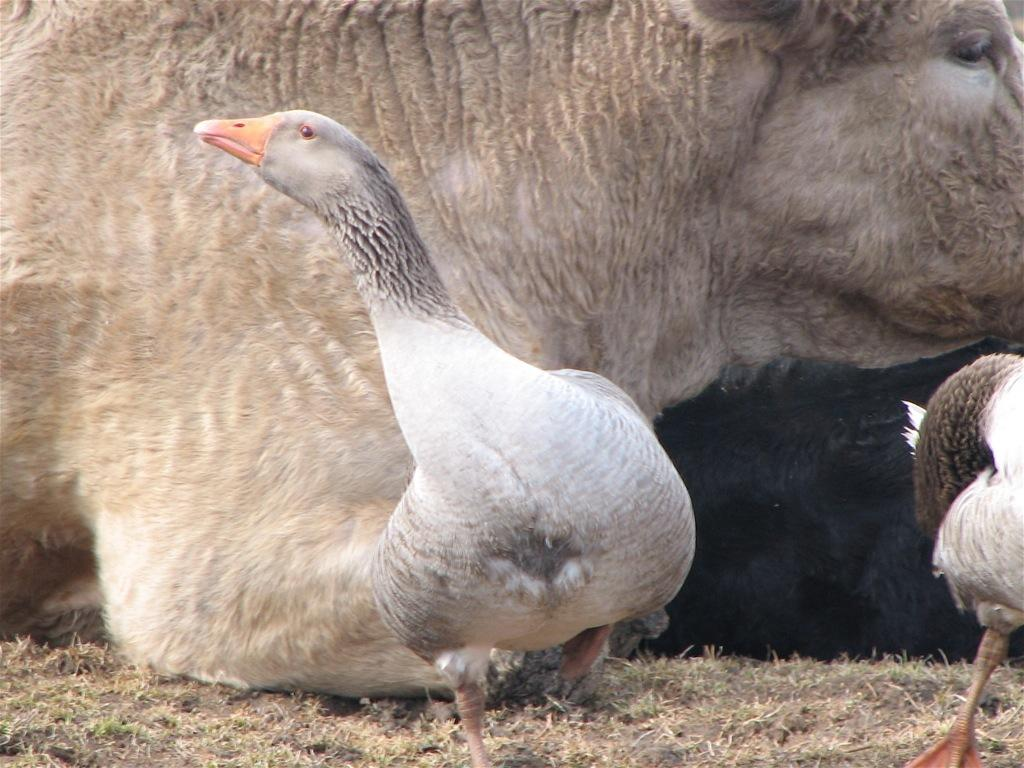What type of animal is in the image? There is a cow in the image. What is the color of the cow? The cow is light brown in color. What other animals are in the image? There are ducks in the image. What colors are the ducks? The ducks are white and black in color. What type of vegetation is visible on the ground in the image? There is grass visible on the ground in the image. What book is the cow reading in the image? There is no book or reading activity present in the image; it features a cow and ducks in a grassy area. 